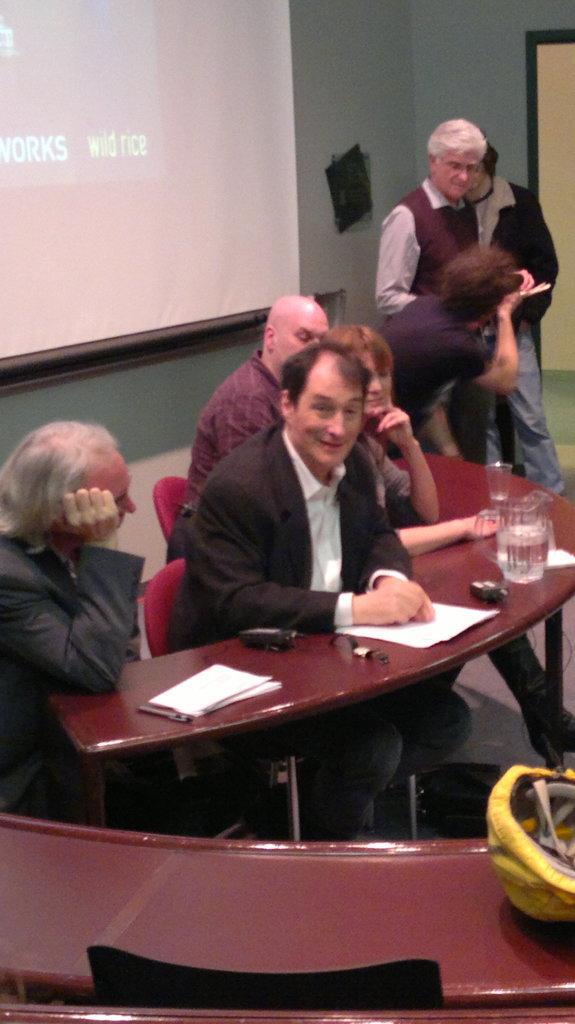Describe this image in one or two sentences. In this image we can see four people are sitting on the chairs near the table. We can see papers, jar and glasses on the table. This is the projector screen. 